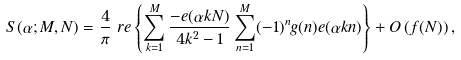<formula> <loc_0><loc_0><loc_500><loc_500>S ( \alpha ; M , N ) & = \frac { 4 } { \pi } \ r e \left \{ \sum _ { k = 1 } ^ { M } \frac { - e ( \alpha k N ) } { 4 k ^ { 2 } - 1 } \sum _ { n = 1 } ^ { M } ( - 1 ) ^ { n } g ( n ) e ( \alpha k n ) \right \} + O \left ( f ( N ) \right ) ,</formula> 